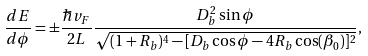<formula> <loc_0><loc_0><loc_500><loc_500>\frac { d E } { d \phi } = \pm \frac { \hbar { v } _ { F } } { 2 L } \frac { D _ { b } ^ { 2 } \sin \phi } { \sqrt { ( 1 + R _ { b } ) ^ { 4 } - [ D _ { b } \cos \phi - 4 R _ { b } \cos ( \beta _ { 0 } ) ] ^ { 2 } } } ,</formula> 